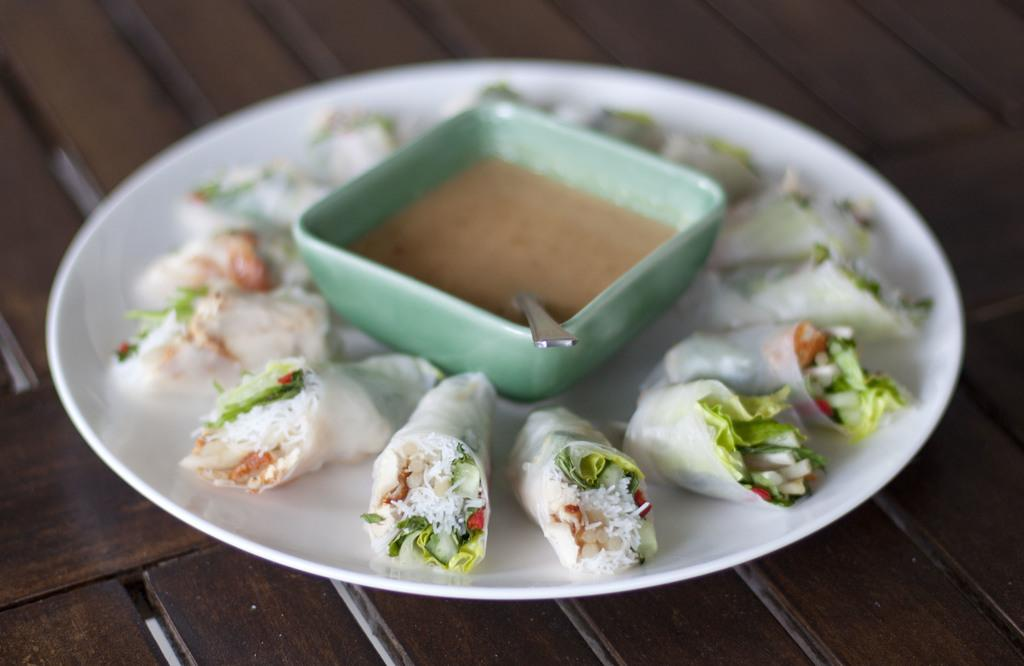What is the main food item visible on the plate in the image? There is a food item on a plate in the image, but the specific type of food cannot be determined from the provided facts. What else is on the plate besides the food item? There is a bowl on the plate in the image. Where is the plate located in the image? The plate is placed on a table in the image. What type of downtown area is visible in the image? There is no downtown area present in the image; it features a plate with a food item and a bowl on a table. Can you describe the magic spell being cast in the image? There is no magic spell or any indication of magic in the image; it simply shows a plate with a food item and a bowl on a table. 